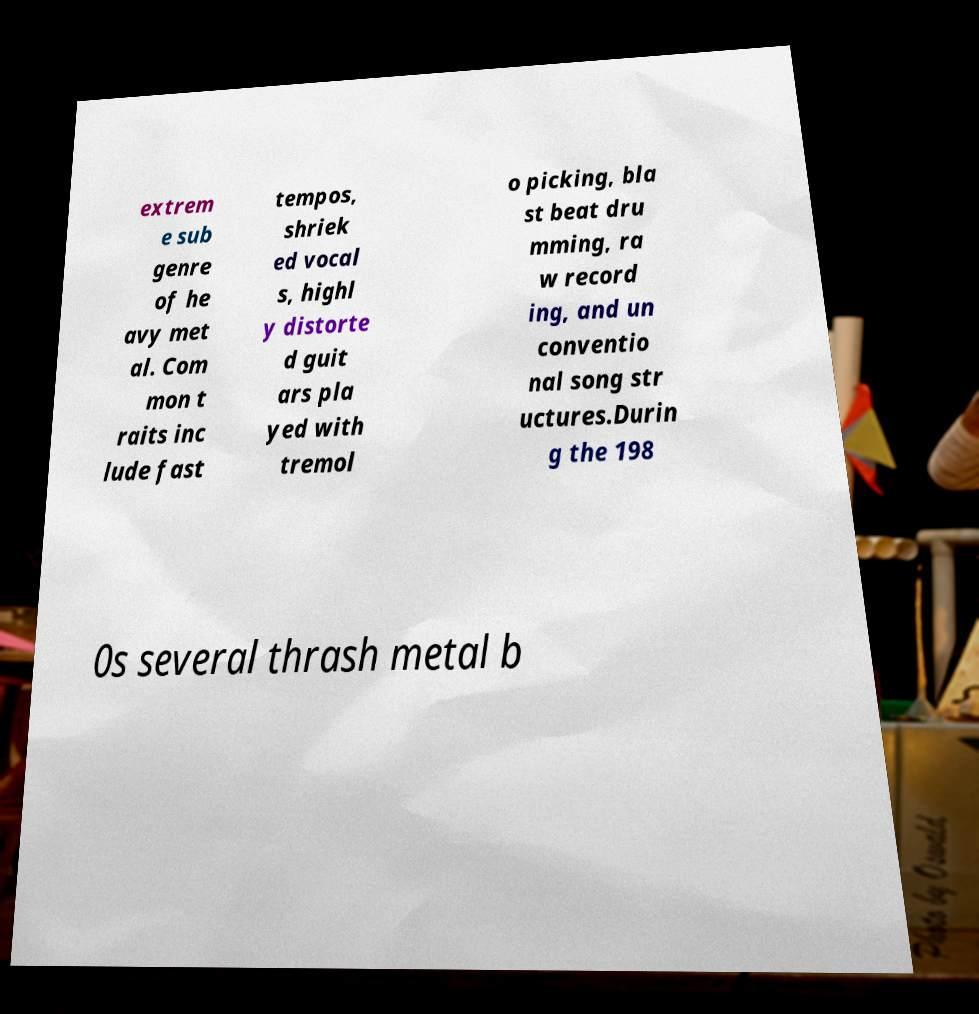Please read and relay the text visible in this image. What does it say? extrem e sub genre of he avy met al. Com mon t raits inc lude fast tempos, shriek ed vocal s, highl y distorte d guit ars pla yed with tremol o picking, bla st beat dru mming, ra w record ing, and un conventio nal song str uctures.Durin g the 198 0s several thrash metal b 